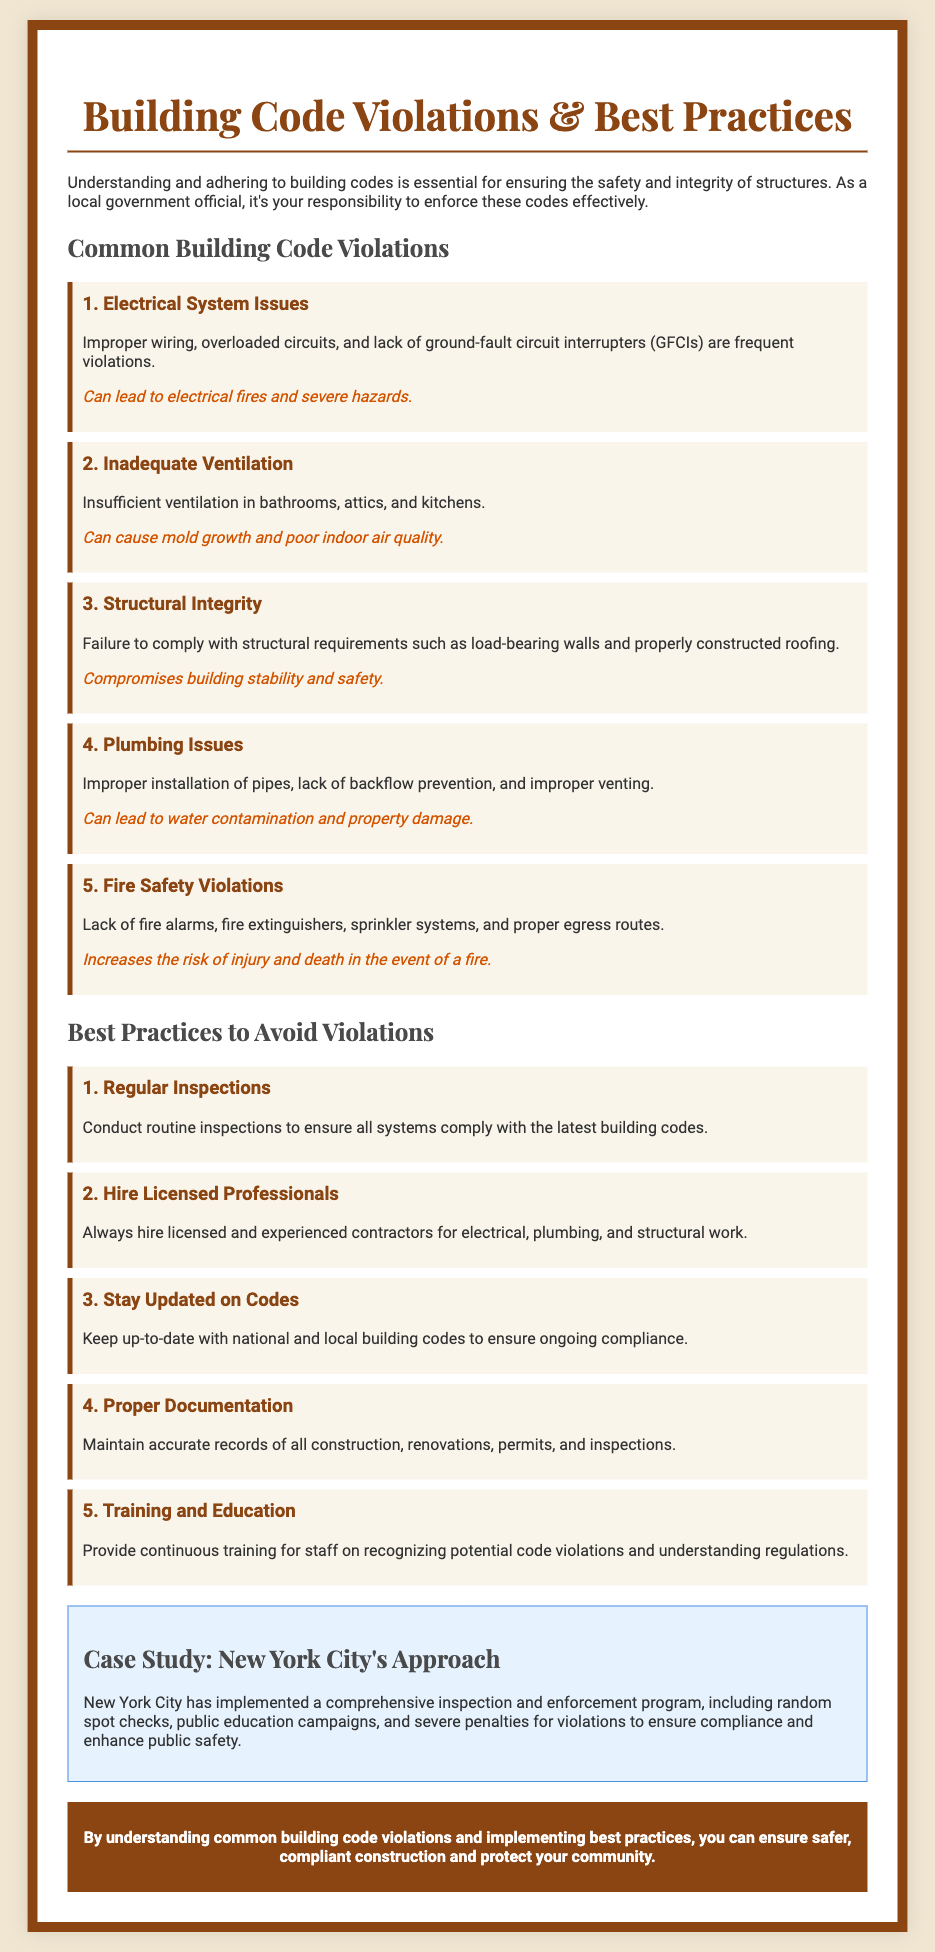What are the five common building code violations listed? The document provides a clear list of five common building code violations, which include Electrical System Issues, Inadequate Ventilation, Structural Integrity, Plumbing Issues, and Fire Safety Violations.
Answer: Electrical System Issues, Inadequate Ventilation, Structural Integrity, Plumbing Issues, Fire Safety Violations What is the consequence of inadequate ventilation? The consequence of inadequate ventilation is mentioned in the document and includes the risk of mold growth and poor indoor air quality.
Answer: Mold growth and poor indoor air quality How many best practices are provided for avoiding violations? The document lists five best practices that can help in avoiding building code violations.
Answer: 5 What approach has New York City implemented for building code enforcement? The document describes New York City's approach as a "comprehensive inspection and enforcement program" that includes random spot checks and public education campaigns.
Answer: Comprehensive inspection and enforcement program Which best practice involves maintaining records? The best practice that involves maintaining records is titled "Proper Documentation".
Answer: Proper Documentation What is the primary purpose of the document? The document aims to educate local government officials on enforcing building codes effectively and ensuring safety in construction.
Answer: Educate local government officials What color is used for the title in the Playbill? The title is in a color specifically mentioned in the document as '#8b4513', which refers to a shade of brown.
Answer: #8b4513 How should professionals be hired to ensure compliance? The document suggests hiring "licensed professionals" to ensure compliance with building codes.
Answer: Licensed professionals 